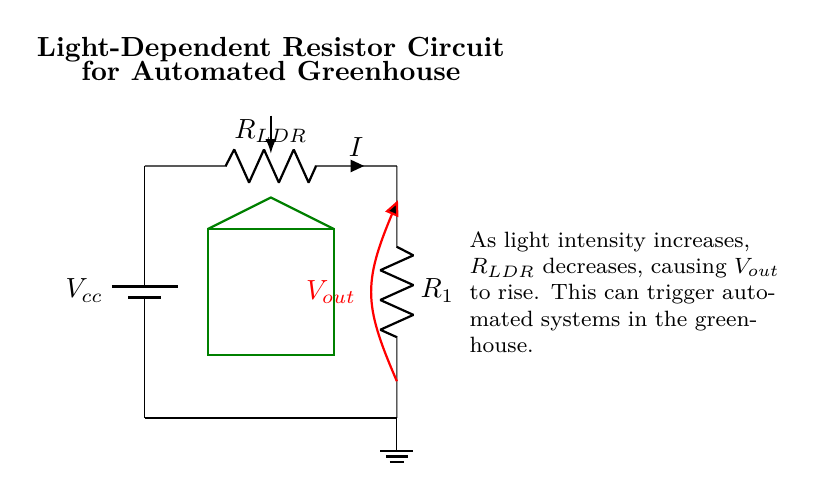What is the component labeled as R L D R? The component labeled as R L D R is a Light-Dependent Resistor that changes resistance based on light intensity.
Answer: Light-Dependent Resistor What happens to the output voltage as light intensity increases? As light intensity increases, the resistance of the Light-Dependent Resistor decreases, causing an increase in the output voltage.
Answer: Output voltage rises What is the purpose of the fixed resistor R1? The fixed resistor R1 helps to limit the current flowing through the circuit, providing stability and protecting components from excessive current.
Answer: Current limiting What is the supply voltage denoted in the circuit? The supply voltage is denoted as Vcc, which is the voltage provided by the battery in the circuit.
Answer: Vcc What does the red line connected to Vout represent? The red line connected to Vout represents the output voltage measurement point, indicating the voltage that can be utilized by other components or systems in the greenhouse setup.
Answer: Output voltage measurement How does the circuit respond to low light levels? In low light levels, the resistance of the Light-Dependent Resistor increases, which reduces the output voltage, and this change can activate the automated systems in the greenhouse accordingly.
Answer: Reduces output voltage How does this circuit contribute to an automated greenhouse system? This circuit automates the greenhouse system by monitoring light conditions; it can trigger actions based on the output voltage changes driven by varying light levels.
Answer: Automates greenhouse 